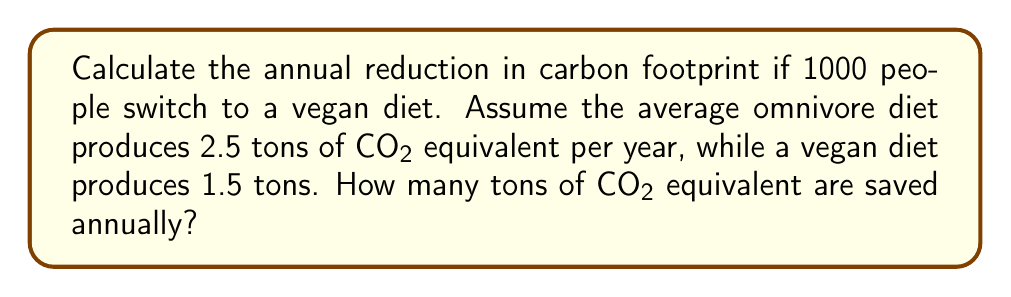Teach me how to tackle this problem. Let's approach this step-by-step:

1. Calculate the carbon footprint for 1000 people on an omnivore diet:
   $$1000 \times 2.5 = 2500 \text{ tons CO₂ equivalent per year}$$

2. Calculate the carbon footprint for 1000 people on a vegan diet:
   $$1000 \times 1.5 = 1500 \text{ tons CO₂ equivalent per year}$$

3. Calculate the difference to find the reduction:
   $$2500 - 1500 = 1000 \text{ tons CO₂ equivalent per year}$$

Therefore, if 1000 people switch from an omnivore diet to a vegan diet, they collectively reduce their carbon footprint by 1000 tons of CO₂ equivalent per year.
Answer: 1000 tons CO₂ equivalent/year 